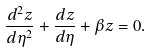Convert formula to latex. <formula><loc_0><loc_0><loc_500><loc_500>\frac { d ^ { 2 } z } { d \eta ^ { 2 } } + \frac { d z } { d \eta } + \beta z = 0 .</formula> 